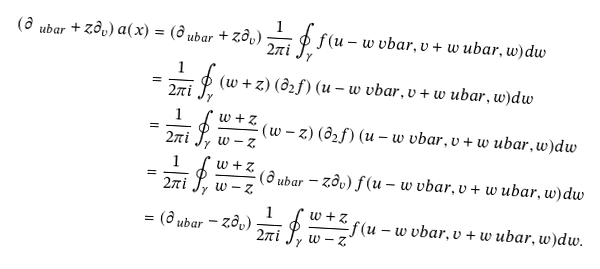<formula> <loc_0><loc_0><loc_500><loc_500>\left ( \partial _ { \ u b a r } + z \partial _ { v } \right ) a ( x ) & = \left ( \partial _ { \ u b a r } + z \partial _ { v } \right ) \frac { 1 } { 2 \pi i } \oint _ { \gamma } f ( u - w \ v b a r , v + w \ u b a r , w ) d w \\ & = \frac { 1 } { 2 \pi i } \oint _ { \gamma } \left ( w + z \right ) \left ( \partial _ { 2 } f \right ) ( u - w \ v b a r , v + w \ u b a r , w ) d w \\ & = \frac { 1 } { 2 \pi i } \oint _ { \gamma } \frac { w + z } { w - z } \left ( w - z \right ) \left ( \partial _ { 2 } f \right ) ( u - w \ v b a r , v + w \ u b a r , w ) d w \\ & = \frac { 1 } { 2 \pi i } \oint _ { \gamma } \frac { w + z } { w - z } \left ( \partial _ { \ u b a r } - z \partial _ { v } \right ) f ( u - w \ v b a r , v + w \ u b a r , w ) d w \\ & = \left ( \partial _ { \ u b a r } - z \partial _ { v } \right ) \frac { 1 } { 2 \pi i } \oint _ { \gamma } \frac { w + z } { w - z } f ( u - w \ v b a r , v + w \ u b a r , w ) d w .</formula> 